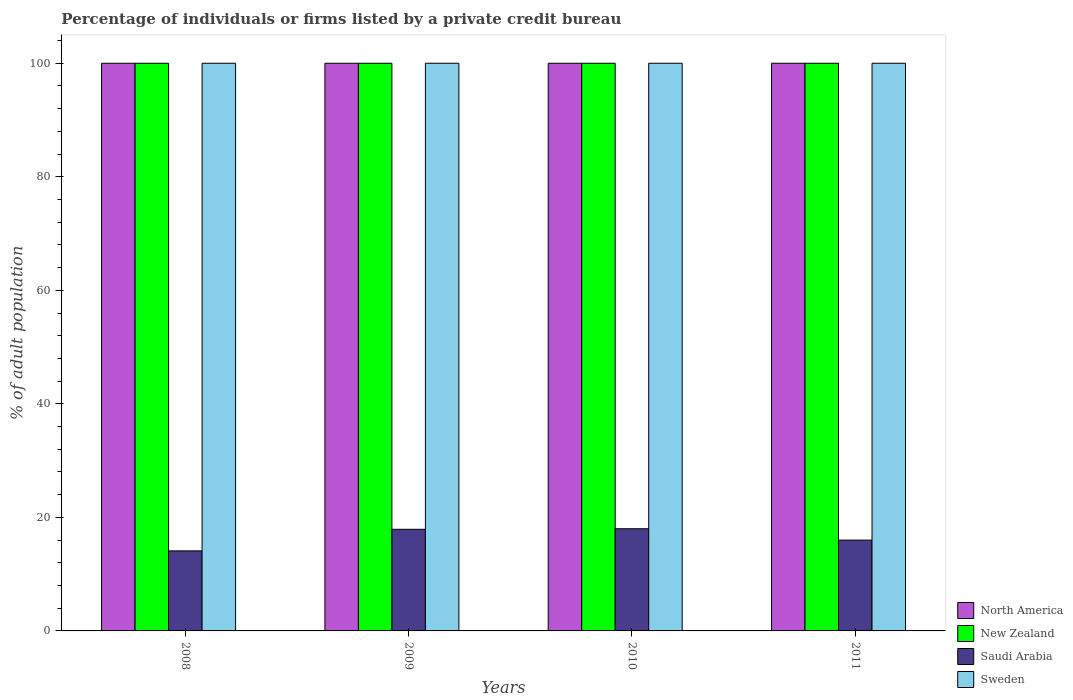How many different coloured bars are there?
Ensure brevity in your answer.  4. How many groups of bars are there?
Your response must be concise. 4. Are the number of bars on each tick of the X-axis equal?
Your answer should be compact. Yes. What is the label of the 1st group of bars from the left?
Your response must be concise. 2008. In how many cases, is the number of bars for a given year not equal to the number of legend labels?
Keep it short and to the point. 0. Across all years, what is the maximum percentage of population listed by a private credit bureau in Saudi Arabia?
Offer a very short reply. 18. In which year was the percentage of population listed by a private credit bureau in North America maximum?
Offer a terse response. 2008. In which year was the percentage of population listed by a private credit bureau in Saudi Arabia minimum?
Give a very brief answer. 2008. What is the total percentage of population listed by a private credit bureau in North America in the graph?
Ensure brevity in your answer.  400. What is the difference between the percentage of population listed by a private credit bureau in North America in 2008 and that in 2010?
Offer a terse response. 0. What is the difference between the percentage of population listed by a private credit bureau in New Zealand in 2011 and the percentage of population listed by a private credit bureau in Saudi Arabia in 2009?
Offer a very short reply. 82.1. What is the average percentage of population listed by a private credit bureau in Saudi Arabia per year?
Give a very brief answer. 16.5. In the year 2009, what is the difference between the percentage of population listed by a private credit bureau in New Zealand and percentage of population listed by a private credit bureau in Sweden?
Provide a short and direct response. 0. In how many years, is the percentage of population listed by a private credit bureau in New Zealand greater than 76 %?
Your answer should be very brief. 4. What is the ratio of the percentage of population listed by a private credit bureau in Saudi Arabia in 2008 to that in 2010?
Ensure brevity in your answer.  0.78. What is the difference between the highest and the second highest percentage of population listed by a private credit bureau in Sweden?
Offer a very short reply. 0. What is the difference between the highest and the lowest percentage of population listed by a private credit bureau in Sweden?
Keep it short and to the point. 0. Is the sum of the percentage of population listed by a private credit bureau in New Zealand in 2008 and 2011 greater than the maximum percentage of population listed by a private credit bureau in Saudi Arabia across all years?
Your response must be concise. Yes. Is it the case that in every year, the sum of the percentage of population listed by a private credit bureau in Saudi Arabia and percentage of population listed by a private credit bureau in North America is greater than the sum of percentage of population listed by a private credit bureau in New Zealand and percentage of population listed by a private credit bureau in Sweden?
Offer a very short reply. No. What does the 3rd bar from the right in 2008 represents?
Your response must be concise. New Zealand. How many bars are there?
Your answer should be very brief. 16. Does the graph contain grids?
Your answer should be very brief. No. Where does the legend appear in the graph?
Your response must be concise. Bottom right. What is the title of the graph?
Offer a terse response. Percentage of individuals or firms listed by a private credit bureau. Does "Upper middle income" appear as one of the legend labels in the graph?
Your answer should be compact. No. What is the label or title of the X-axis?
Give a very brief answer. Years. What is the label or title of the Y-axis?
Ensure brevity in your answer.  % of adult population. What is the % of adult population of North America in 2008?
Your answer should be compact. 100. What is the % of adult population in New Zealand in 2008?
Your answer should be very brief. 100. What is the % of adult population of Saudi Arabia in 2008?
Provide a short and direct response. 14.1. What is the % of adult population of Sweden in 2008?
Your answer should be compact. 100. What is the % of adult population in North America in 2009?
Provide a short and direct response. 100. What is the % of adult population in Sweden in 2009?
Give a very brief answer. 100. What is the % of adult population in North America in 2010?
Your response must be concise. 100. What is the % of adult population in New Zealand in 2010?
Provide a short and direct response. 100. What is the % of adult population of Sweden in 2010?
Offer a very short reply. 100. What is the % of adult population in New Zealand in 2011?
Provide a short and direct response. 100. Across all years, what is the maximum % of adult population in Saudi Arabia?
Offer a terse response. 18. Across all years, what is the minimum % of adult population in Sweden?
Give a very brief answer. 100. What is the total % of adult population in North America in the graph?
Keep it short and to the point. 400. What is the total % of adult population of Saudi Arabia in the graph?
Ensure brevity in your answer.  66. What is the total % of adult population of Sweden in the graph?
Provide a succinct answer. 400. What is the difference between the % of adult population of Saudi Arabia in 2008 and that in 2009?
Provide a short and direct response. -3.8. What is the difference between the % of adult population of New Zealand in 2008 and that in 2010?
Give a very brief answer. 0. What is the difference between the % of adult population in New Zealand in 2008 and that in 2011?
Offer a terse response. 0. What is the difference between the % of adult population in Sweden in 2008 and that in 2011?
Offer a terse response. 0. What is the difference between the % of adult population in North America in 2009 and that in 2010?
Your answer should be compact. 0. What is the difference between the % of adult population of New Zealand in 2009 and that in 2011?
Offer a terse response. 0. What is the difference between the % of adult population of Sweden in 2009 and that in 2011?
Give a very brief answer. 0. What is the difference between the % of adult population of New Zealand in 2010 and that in 2011?
Provide a succinct answer. 0. What is the difference between the % of adult population in Sweden in 2010 and that in 2011?
Ensure brevity in your answer.  0. What is the difference between the % of adult population in North America in 2008 and the % of adult population in Saudi Arabia in 2009?
Offer a terse response. 82.1. What is the difference between the % of adult population of North America in 2008 and the % of adult population of Sweden in 2009?
Ensure brevity in your answer.  0. What is the difference between the % of adult population in New Zealand in 2008 and the % of adult population in Saudi Arabia in 2009?
Keep it short and to the point. 82.1. What is the difference between the % of adult population in Saudi Arabia in 2008 and the % of adult population in Sweden in 2009?
Your answer should be compact. -85.9. What is the difference between the % of adult population of Saudi Arabia in 2008 and the % of adult population of Sweden in 2010?
Provide a succinct answer. -85.9. What is the difference between the % of adult population in North America in 2008 and the % of adult population in Saudi Arabia in 2011?
Offer a very short reply. 84. What is the difference between the % of adult population of North America in 2008 and the % of adult population of Sweden in 2011?
Make the answer very short. 0. What is the difference between the % of adult population of New Zealand in 2008 and the % of adult population of Saudi Arabia in 2011?
Make the answer very short. 84. What is the difference between the % of adult population in Saudi Arabia in 2008 and the % of adult population in Sweden in 2011?
Ensure brevity in your answer.  -85.9. What is the difference between the % of adult population in North America in 2009 and the % of adult population in New Zealand in 2010?
Give a very brief answer. 0. What is the difference between the % of adult population in New Zealand in 2009 and the % of adult population in Saudi Arabia in 2010?
Ensure brevity in your answer.  82. What is the difference between the % of adult population of Saudi Arabia in 2009 and the % of adult population of Sweden in 2010?
Give a very brief answer. -82.1. What is the difference between the % of adult population of North America in 2009 and the % of adult population of New Zealand in 2011?
Your answer should be compact. 0. What is the difference between the % of adult population of New Zealand in 2009 and the % of adult population of Saudi Arabia in 2011?
Your answer should be very brief. 84. What is the difference between the % of adult population in New Zealand in 2009 and the % of adult population in Sweden in 2011?
Make the answer very short. 0. What is the difference between the % of adult population in Saudi Arabia in 2009 and the % of adult population in Sweden in 2011?
Keep it short and to the point. -82.1. What is the difference between the % of adult population of North America in 2010 and the % of adult population of Saudi Arabia in 2011?
Offer a terse response. 84. What is the difference between the % of adult population of North America in 2010 and the % of adult population of Sweden in 2011?
Your response must be concise. 0. What is the difference between the % of adult population of New Zealand in 2010 and the % of adult population of Saudi Arabia in 2011?
Your response must be concise. 84. What is the difference between the % of adult population of New Zealand in 2010 and the % of adult population of Sweden in 2011?
Provide a succinct answer. 0. What is the difference between the % of adult population in Saudi Arabia in 2010 and the % of adult population in Sweden in 2011?
Your answer should be very brief. -82. What is the average % of adult population in North America per year?
Make the answer very short. 100. What is the average % of adult population in Saudi Arabia per year?
Ensure brevity in your answer.  16.5. What is the average % of adult population of Sweden per year?
Offer a terse response. 100. In the year 2008, what is the difference between the % of adult population of North America and % of adult population of Saudi Arabia?
Provide a short and direct response. 85.9. In the year 2008, what is the difference between the % of adult population of North America and % of adult population of Sweden?
Offer a very short reply. 0. In the year 2008, what is the difference between the % of adult population in New Zealand and % of adult population in Saudi Arabia?
Your response must be concise. 85.9. In the year 2008, what is the difference between the % of adult population in New Zealand and % of adult population in Sweden?
Your answer should be compact. 0. In the year 2008, what is the difference between the % of adult population of Saudi Arabia and % of adult population of Sweden?
Offer a terse response. -85.9. In the year 2009, what is the difference between the % of adult population in North America and % of adult population in Saudi Arabia?
Provide a short and direct response. 82.1. In the year 2009, what is the difference between the % of adult population in New Zealand and % of adult population in Saudi Arabia?
Offer a terse response. 82.1. In the year 2009, what is the difference between the % of adult population in New Zealand and % of adult population in Sweden?
Offer a very short reply. 0. In the year 2009, what is the difference between the % of adult population in Saudi Arabia and % of adult population in Sweden?
Keep it short and to the point. -82.1. In the year 2010, what is the difference between the % of adult population of North America and % of adult population of Saudi Arabia?
Provide a short and direct response. 82. In the year 2010, what is the difference between the % of adult population of North America and % of adult population of Sweden?
Provide a succinct answer. 0. In the year 2010, what is the difference between the % of adult population of New Zealand and % of adult population of Saudi Arabia?
Offer a terse response. 82. In the year 2010, what is the difference between the % of adult population in New Zealand and % of adult population in Sweden?
Your answer should be very brief. 0. In the year 2010, what is the difference between the % of adult population of Saudi Arabia and % of adult population of Sweden?
Your answer should be compact. -82. In the year 2011, what is the difference between the % of adult population in North America and % of adult population in New Zealand?
Your answer should be very brief. 0. In the year 2011, what is the difference between the % of adult population in North America and % of adult population in Saudi Arabia?
Your answer should be very brief. 84. In the year 2011, what is the difference between the % of adult population in New Zealand and % of adult population in Saudi Arabia?
Your answer should be compact. 84. In the year 2011, what is the difference between the % of adult population of Saudi Arabia and % of adult population of Sweden?
Provide a succinct answer. -84. What is the ratio of the % of adult population of Saudi Arabia in 2008 to that in 2009?
Make the answer very short. 0.79. What is the ratio of the % of adult population in North America in 2008 to that in 2010?
Your answer should be compact. 1. What is the ratio of the % of adult population in New Zealand in 2008 to that in 2010?
Your answer should be very brief. 1. What is the ratio of the % of adult population in Saudi Arabia in 2008 to that in 2010?
Your answer should be compact. 0.78. What is the ratio of the % of adult population in North America in 2008 to that in 2011?
Give a very brief answer. 1. What is the ratio of the % of adult population of New Zealand in 2008 to that in 2011?
Provide a short and direct response. 1. What is the ratio of the % of adult population of Saudi Arabia in 2008 to that in 2011?
Provide a succinct answer. 0.88. What is the ratio of the % of adult population in Sweden in 2008 to that in 2011?
Keep it short and to the point. 1. What is the ratio of the % of adult population of New Zealand in 2009 to that in 2011?
Ensure brevity in your answer.  1. What is the ratio of the % of adult population in Saudi Arabia in 2009 to that in 2011?
Your answer should be very brief. 1.12. What is the ratio of the % of adult population in New Zealand in 2010 to that in 2011?
Offer a terse response. 1. What is the ratio of the % of adult population of Sweden in 2010 to that in 2011?
Your answer should be compact. 1. What is the difference between the highest and the second highest % of adult population in North America?
Offer a terse response. 0. What is the difference between the highest and the second highest % of adult population in New Zealand?
Your answer should be very brief. 0. 